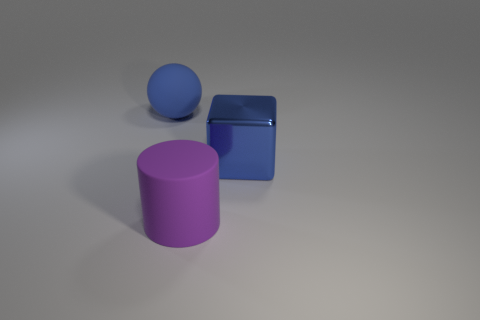Add 2 metallic balls. How many objects exist? 5 Subtract all spheres. How many objects are left? 2 Subtract 0 purple cubes. How many objects are left? 3 Subtract all big blue matte things. Subtract all metal cubes. How many objects are left? 1 Add 1 blue metal cubes. How many blue metal cubes are left? 2 Add 3 big blue blocks. How many big blue blocks exist? 4 